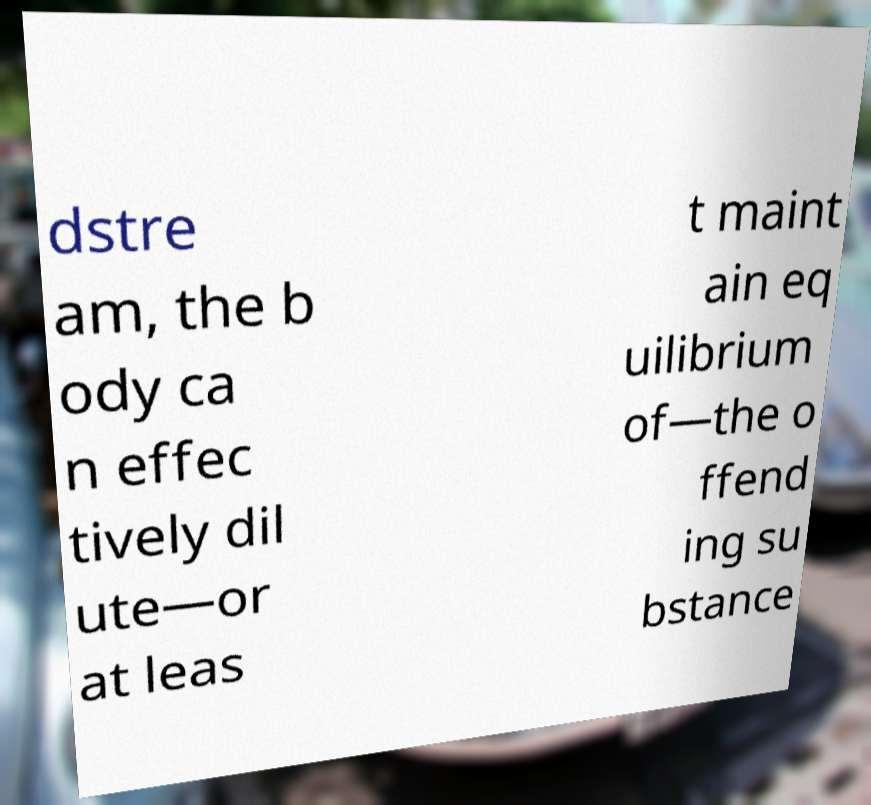I need the written content from this picture converted into text. Can you do that? dstre am, the b ody ca n effec tively dil ute—or at leas t maint ain eq uilibrium of—the o ffend ing su bstance 